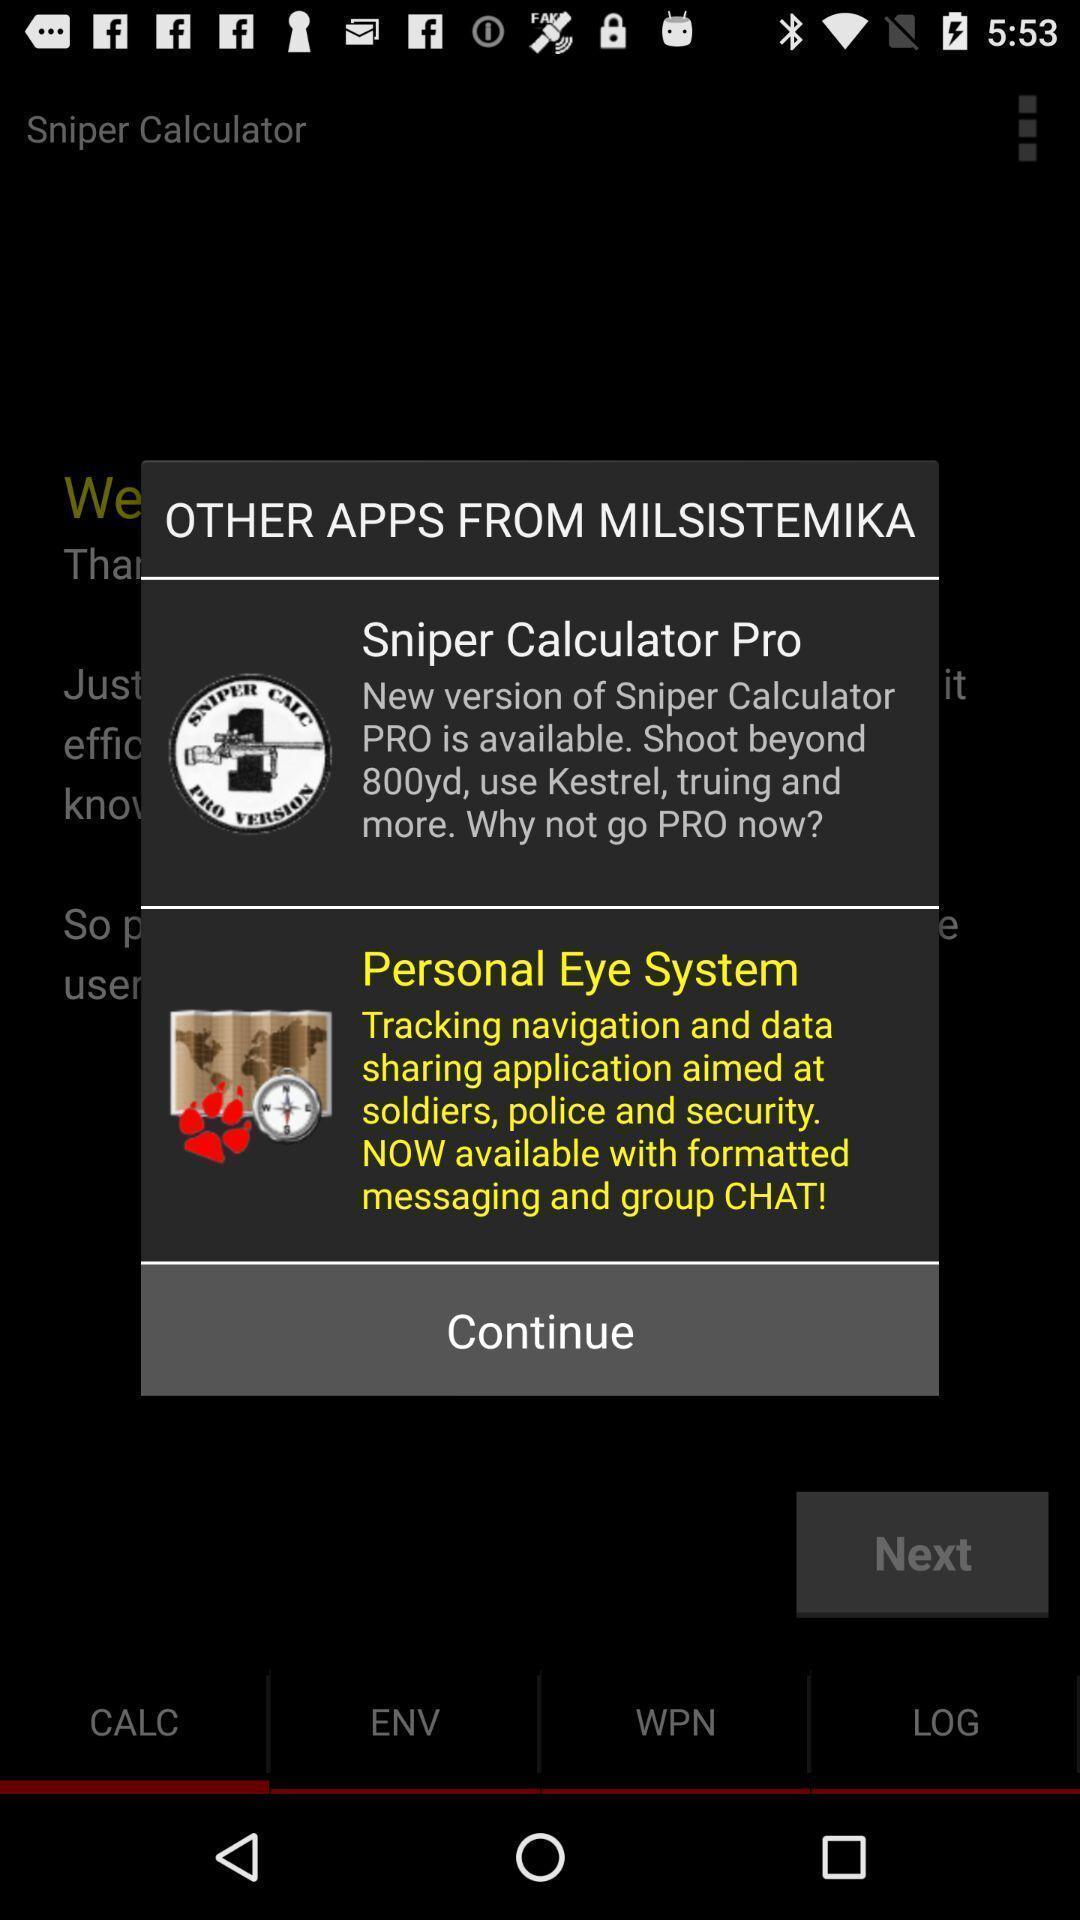Explain the elements present in this screenshot. Pop-up suggesting multiple apps. 